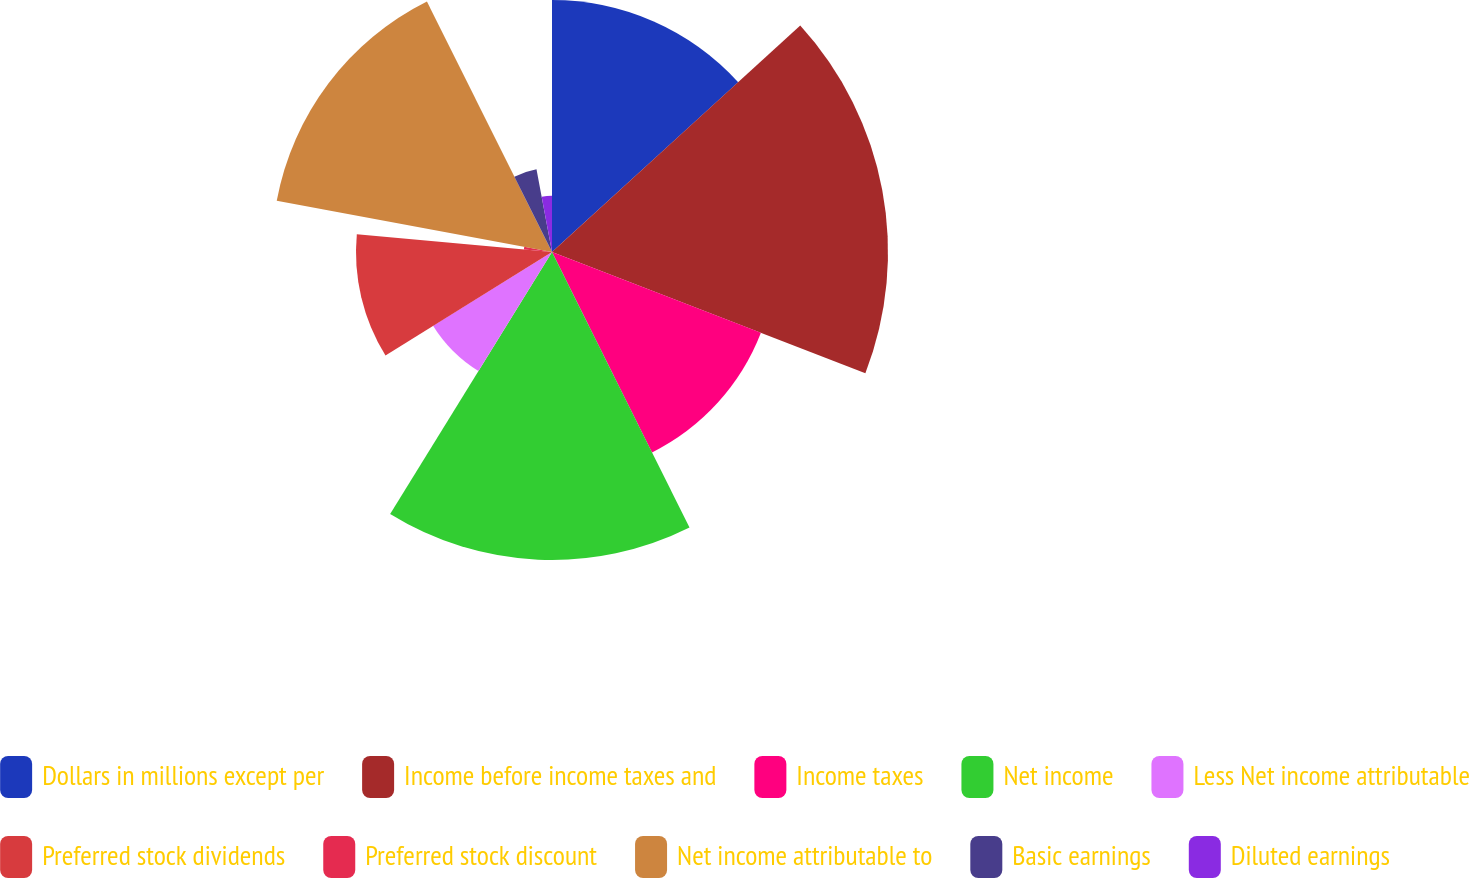Convert chart to OTSL. <chart><loc_0><loc_0><loc_500><loc_500><pie_chart><fcel>Dollars in millions except per<fcel>Income before income taxes and<fcel>Income taxes<fcel>Net income<fcel>Less Net income attributable<fcel>Preferred stock dividends<fcel>Preferred stock discount<fcel>Net income attributable to<fcel>Basic earnings<fcel>Diluted earnings<nl><fcel>13.23%<fcel>17.64%<fcel>11.76%<fcel>16.17%<fcel>7.35%<fcel>10.29%<fcel>1.48%<fcel>14.7%<fcel>4.42%<fcel>2.95%<nl></chart> 